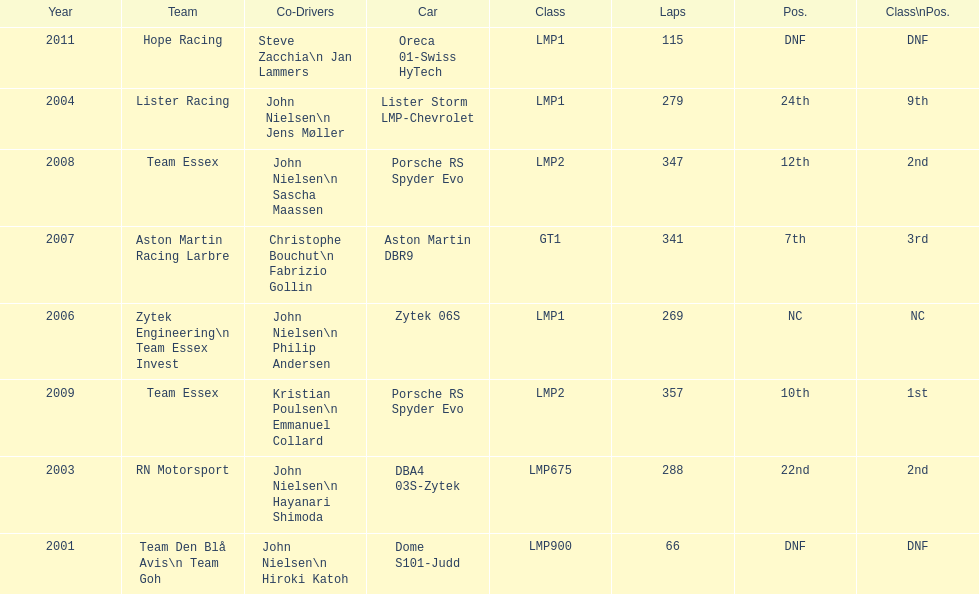How many times was the final position above 20? 2. 